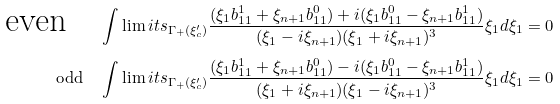Convert formula to latex. <formula><loc_0><loc_0><loc_500><loc_500>\text {even} \quad & \int \lim i t s _ { \Gamma _ { + } ( \xi ^ { \prime } _ { c } ) } \frac { ( \xi _ { 1 } b ^ { 1 } _ { 1 1 } + \xi _ { n + 1 } b ^ { 0 } _ { 1 1 } ) + i ( \xi _ { 1 } b ^ { 0 } _ { 1 1 } - \xi _ { n + 1 } b ^ { 1 } _ { 1 1 } ) } { ( \xi _ { 1 } - i \xi _ { n + 1 } ) ( \xi _ { 1 } + i \xi _ { n + 1 } ) ^ { 3 } } \xi _ { 1 } d \xi _ { 1 } = 0 \\ \text {odd} \quad & \int \lim i t s _ { \Gamma _ { + } ( \xi ^ { \prime } _ { c } ) } \frac { ( \xi _ { 1 } b ^ { 1 } _ { 1 1 } + \xi _ { n + 1 } b ^ { 0 } _ { 1 1 } ) - i ( \xi _ { 1 } b ^ { 0 } _ { 1 1 } - \xi _ { n + 1 } b ^ { 1 } _ { 1 1 } ) } { ( \xi _ { 1 } + i \xi _ { n + 1 } ) ( \xi _ { 1 } - i \xi _ { n + 1 } ) ^ { 3 } } \xi _ { 1 } d \xi _ { 1 } = 0</formula> 